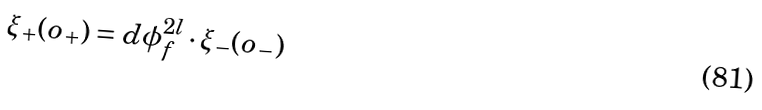<formula> <loc_0><loc_0><loc_500><loc_500>\xi _ { + } ( o _ { + } ) = d \phi _ { f } ^ { 2 l } \cdot \xi _ { - } ( o _ { - } )</formula> 